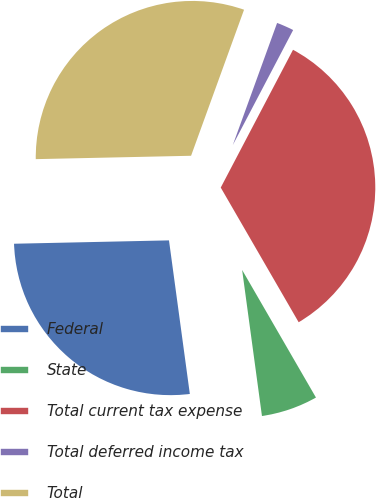Convert chart to OTSL. <chart><loc_0><loc_0><loc_500><loc_500><pie_chart><fcel>Federal<fcel>State<fcel>Total current tax expense<fcel>Total deferred income tax<fcel>Total<nl><fcel>26.8%<fcel>6.2%<fcel>33.96%<fcel>2.15%<fcel>30.88%<nl></chart> 